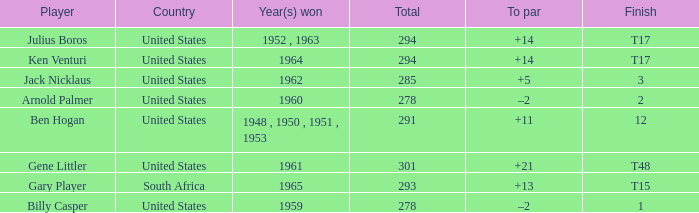What is Year(s) Won, when Total is less than 285? 1959, 1960. 